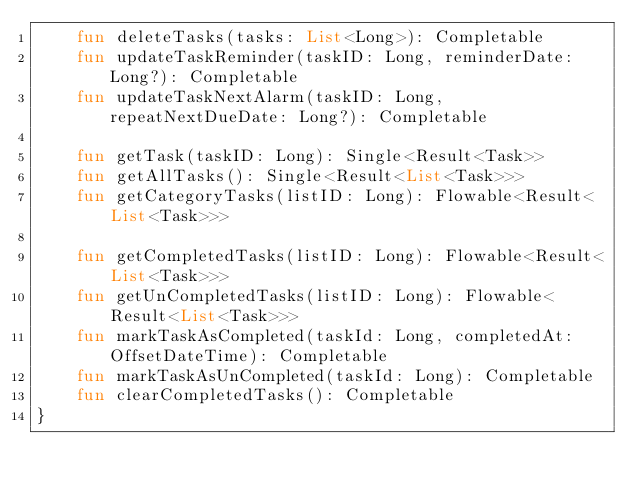<code> <loc_0><loc_0><loc_500><loc_500><_Kotlin_>    fun deleteTasks(tasks: List<Long>): Completable
    fun updateTaskReminder(taskID: Long, reminderDate: Long?): Completable
    fun updateTaskNextAlarm(taskID: Long, repeatNextDueDate: Long?): Completable

    fun getTask(taskID: Long): Single<Result<Task>>
    fun getAllTasks(): Single<Result<List<Task>>>
    fun getCategoryTasks(listID: Long): Flowable<Result<List<Task>>>

    fun getCompletedTasks(listID: Long): Flowable<Result<List<Task>>>
    fun getUnCompletedTasks(listID: Long): Flowable<Result<List<Task>>>
    fun markTaskAsCompleted(taskId: Long, completedAt: OffsetDateTime): Completable
    fun markTaskAsUnCompleted(taskId: Long): Completable
    fun clearCompletedTasks(): Completable
}</code> 